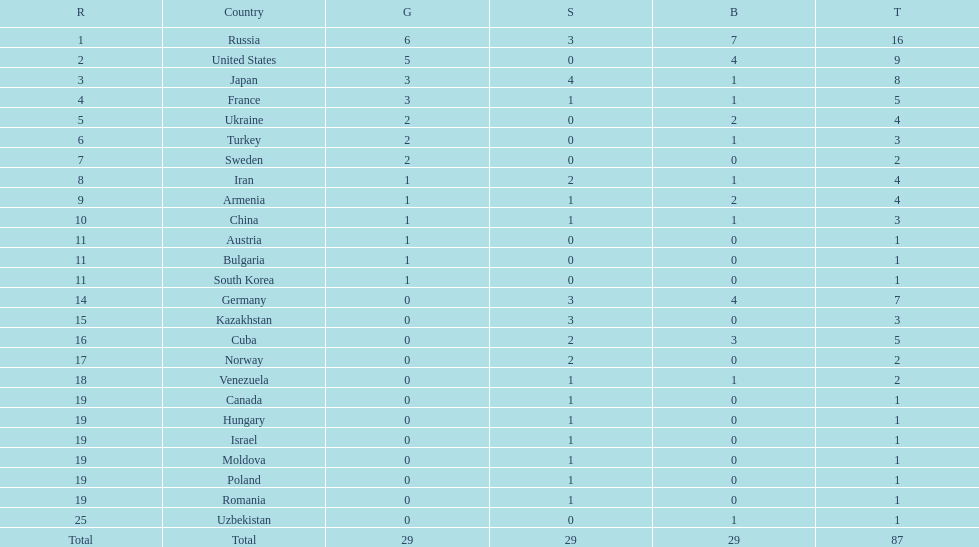How many countries have over 5 bronze medals in total? 1. 